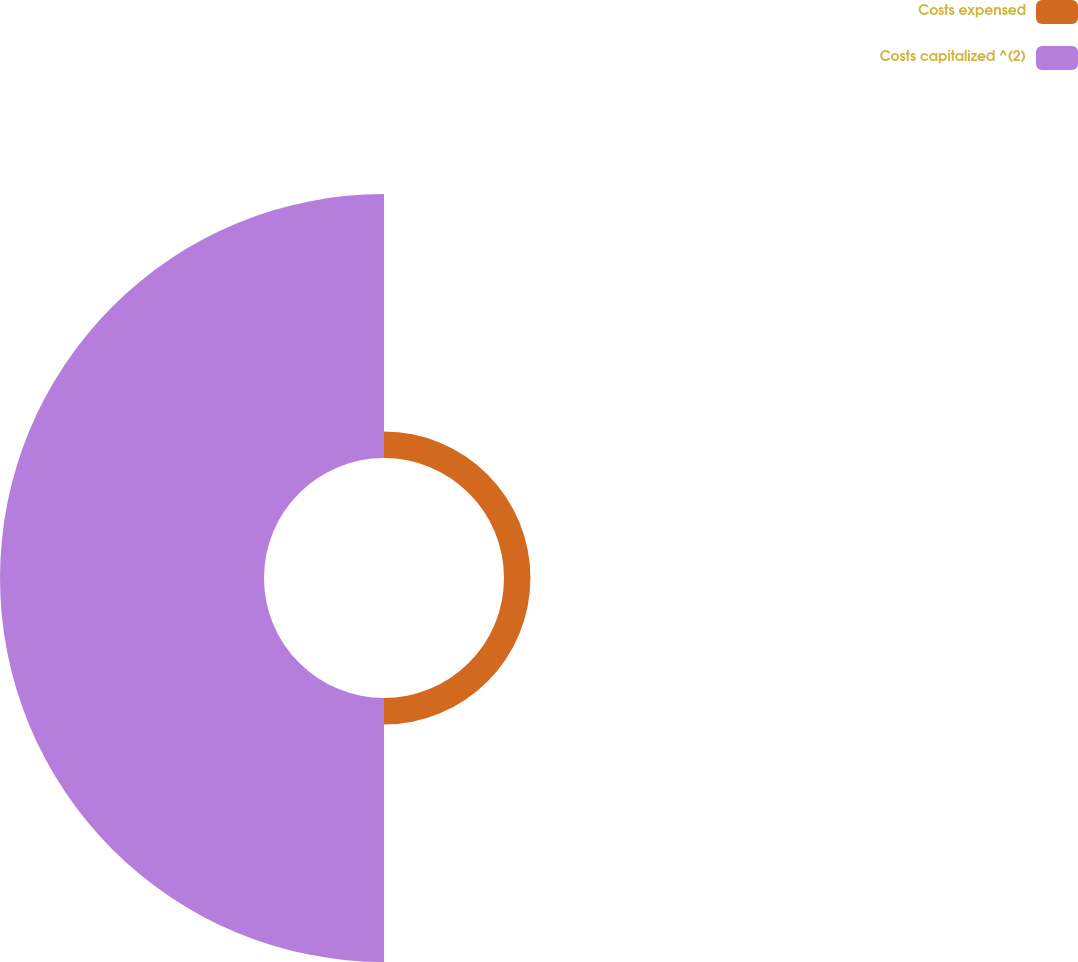<chart> <loc_0><loc_0><loc_500><loc_500><pie_chart><fcel>Costs expensed<fcel>Costs capitalized ^(2)<nl><fcel>9.11%<fcel>90.89%<nl></chart> 